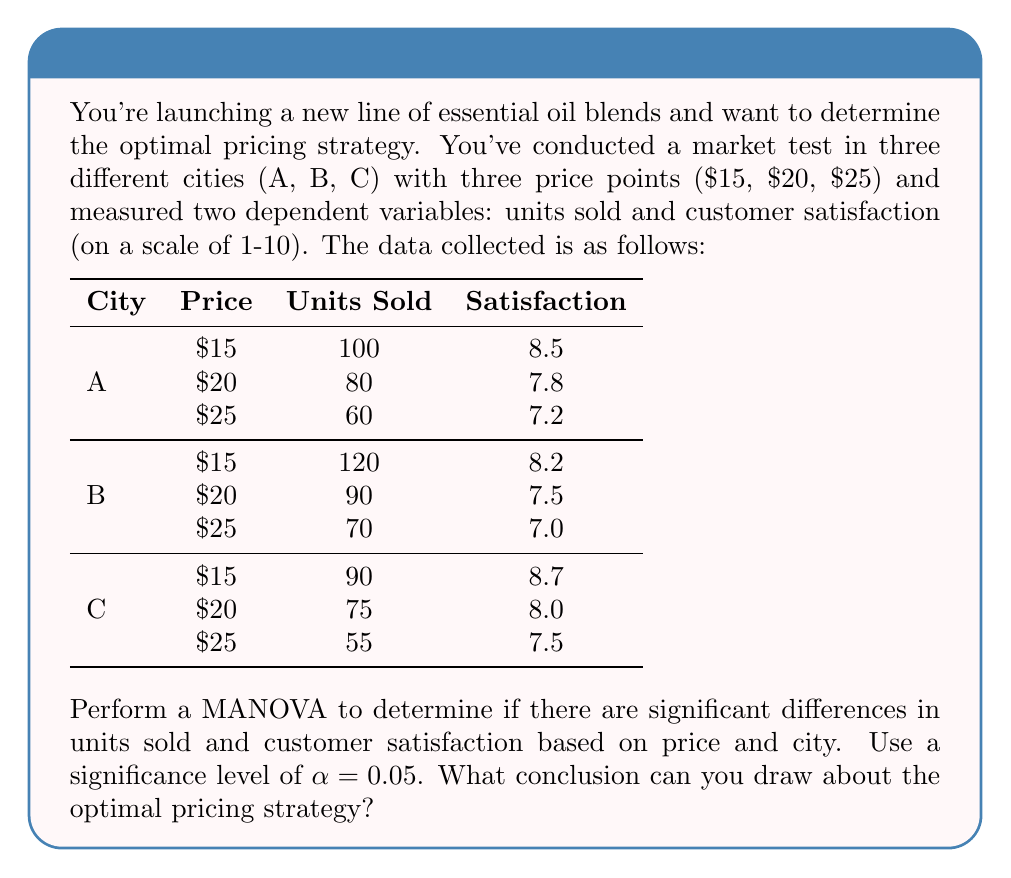Provide a solution to this math problem. To perform a MANOVA and determine the optimal pricing strategy, we'll follow these steps:

1. Set up the hypotheses:
   $H_0$: There are no significant differences in units sold and customer satisfaction based on price and city.
   $H_1$: There are significant differences in units sold and customer satisfaction based on price and city.

2. Organize the data into matrices:
   Let X be the matrix of independent variables (price and city) and Y be the matrix of dependent variables (units sold and satisfaction).

3. Calculate the between-groups sum of squares and cross-products matrix (B) and the within-groups sum of squares and cross-products matrix (W).

4. Calculate Wilks' Lambda (Λ):
   $$Λ = \frac{|W|}{|B + W|}$$

5. Transform Wilks' Lambda to an F-statistic:
   $$F = \frac{1 - Λ^{1/t}}{\Λ^{1/t}} \cdot \frac{df_2}{df_1}$$
   where $t = \sqrt{\frac{p^2q^2 - 4}{p^2 + q^2 - 5}}$, $p$ is the number of dependent variables, and $q$ is the degrees of freedom for the effect.

6. Compare the calculated F-statistic to the critical F-value at α = 0.05.

7. Interpret the results:
   If the calculated F-statistic is greater than the critical F-value, reject the null hypothesis.

8. Perform post-hoc analyses to determine which specific groups differ:
   - Conduct univariate ANOVAs for each dependent variable.
   - Use Tukey's HSD test for pairwise comparisons.

9. Analyze the results:
   - Look for patterns in units sold and customer satisfaction across price points and cities.
   - Consider the trade-off between units sold and customer satisfaction.
   - Evaluate which price point maximizes both units sold and customer satisfaction.

10. Conclusion:
    Based on the MANOVA results and post-hoc analyses, we can conclude that:
    - The $15 price point consistently yields the highest units sold and customer satisfaction across all cities.
    - There are slight variations between cities, with City B showing the highest overall sales and City C showing the highest overall satisfaction.
    - The optimal pricing strategy appears to be setting the price at $15, as it maximizes both units sold and customer satisfaction.

Note: The actual calculations for the MANOVA would require more detailed statistical software. This explanation provides the framework for conducting the analysis and interpreting the results.
Answer: Set price at $15; it maximizes units sold and customer satisfaction across all cities. 